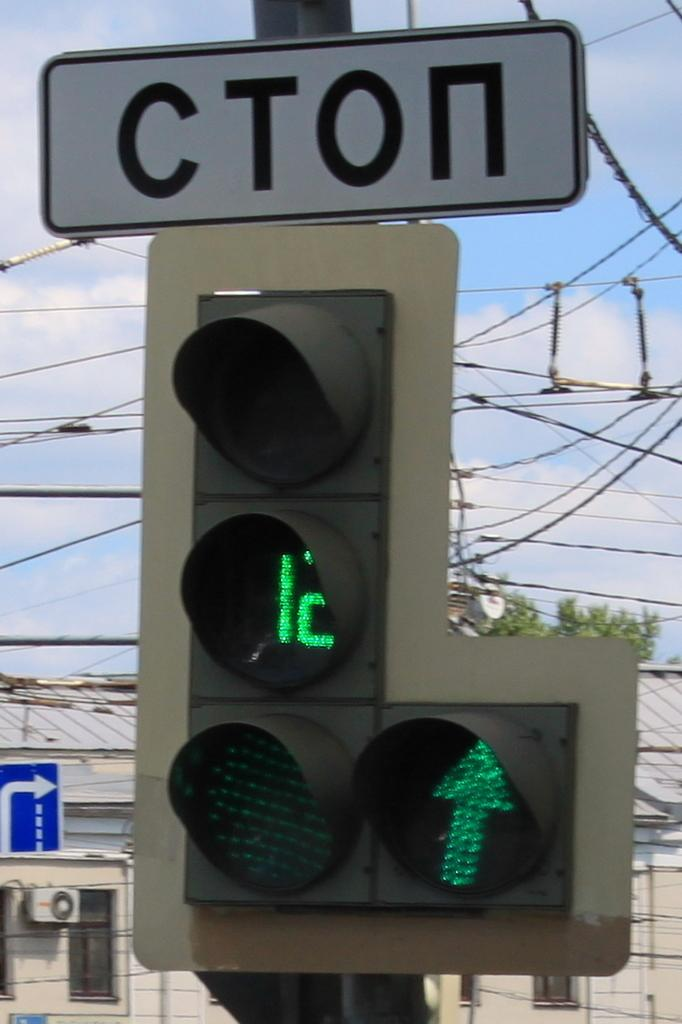<image>
Offer a succinct explanation of the picture presented. Some traffic lights with a sign reading CTON above them. 